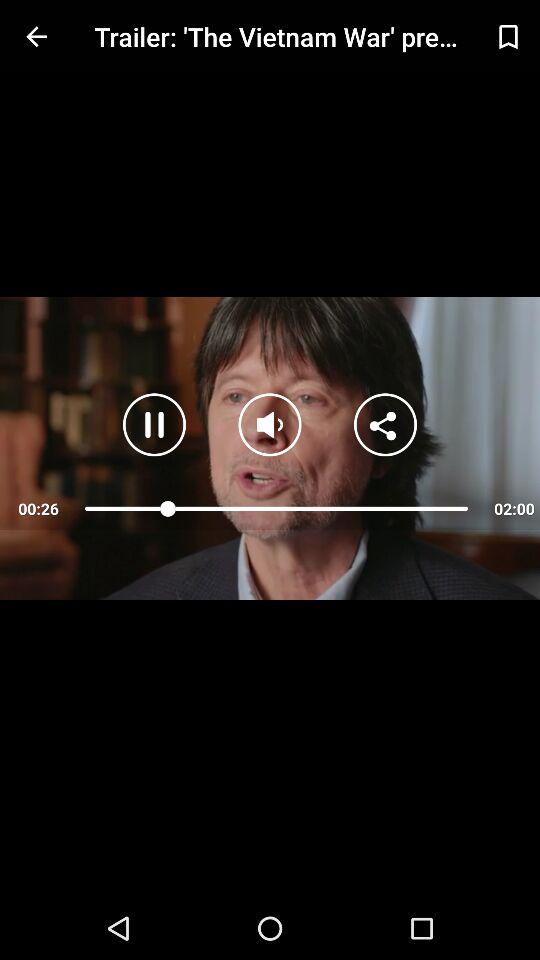What is the volume level of the video?
When the provided information is insufficient, respond with <no answer>. <no answer> 